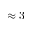Convert formula to latex. <formula><loc_0><loc_0><loc_500><loc_500>\approx 3</formula> 